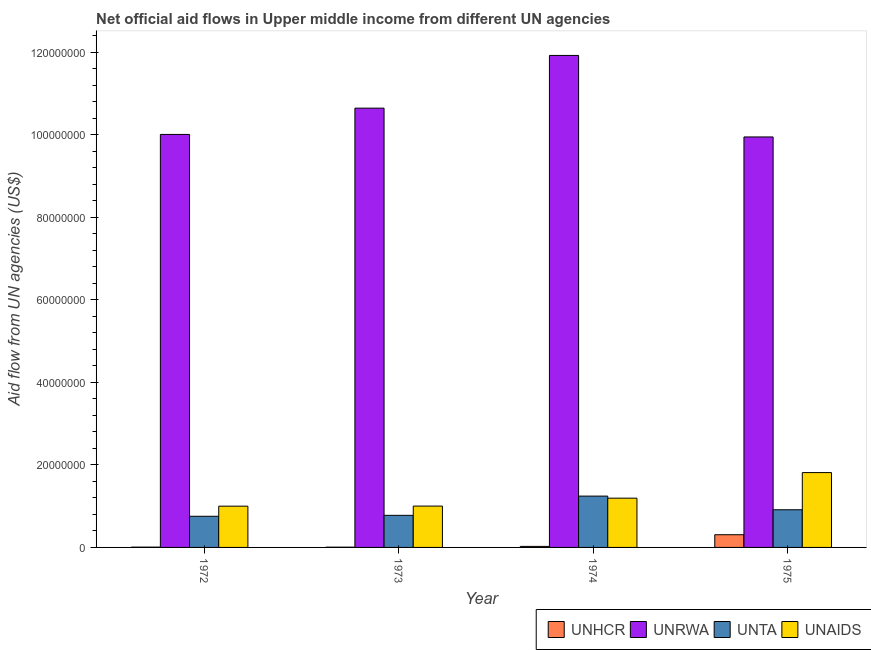How many groups of bars are there?
Offer a terse response. 4. Are the number of bars per tick equal to the number of legend labels?
Your answer should be very brief. Yes. How many bars are there on the 1st tick from the right?
Offer a terse response. 4. What is the label of the 4th group of bars from the left?
Provide a short and direct response. 1975. In how many cases, is the number of bars for a given year not equal to the number of legend labels?
Offer a terse response. 0. What is the amount of aid given by unta in 1974?
Provide a short and direct response. 1.24e+07. Across all years, what is the maximum amount of aid given by unaids?
Provide a short and direct response. 1.81e+07. Across all years, what is the minimum amount of aid given by unrwa?
Make the answer very short. 9.95e+07. In which year was the amount of aid given by unrwa maximum?
Make the answer very short. 1974. What is the total amount of aid given by unrwa in the graph?
Make the answer very short. 4.25e+08. What is the difference between the amount of aid given by unta in 1973 and that in 1974?
Give a very brief answer. -4.66e+06. What is the difference between the amount of aid given by unta in 1974 and the amount of aid given by unhcr in 1973?
Keep it short and to the point. 4.66e+06. What is the average amount of aid given by unaids per year?
Ensure brevity in your answer.  1.25e+07. In how many years, is the amount of aid given by unaids greater than 36000000 US$?
Offer a very short reply. 0. What is the ratio of the amount of aid given by unrwa in 1973 to that in 1974?
Your answer should be very brief. 0.89. What is the difference between the highest and the second highest amount of aid given by unaids?
Your answer should be compact. 6.20e+06. What is the difference between the highest and the lowest amount of aid given by unrwa?
Keep it short and to the point. 1.98e+07. Is the sum of the amount of aid given by unaids in 1972 and 1974 greater than the maximum amount of aid given by unrwa across all years?
Ensure brevity in your answer.  Yes. Is it the case that in every year, the sum of the amount of aid given by unta and amount of aid given by unaids is greater than the sum of amount of aid given by unhcr and amount of aid given by unrwa?
Your response must be concise. No. What does the 3rd bar from the left in 1975 represents?
Provide a short and direct response. UNTA. What does the 3rd bar from the right in 1972 represents?
Keep it short and to the point. UNRWA. How many bars are there?
Provide a succinct answer. 16. Are all the bars in the graph horizontal?
Your response must be concise. No. Does the graph contain any zero values?
Offer a terse response. No. Where does the legend appear in the graph?
Offer a very short reply. Bottom right. How are the legend labels stacked?
Keep it short and to the point. Horizontal. What is the title of the graph?
Provide a short and direct response. Net official aid flows in Upper middle income from different UN agencies. Does "Services" appear as one of the legend labels in the graph?
Make the answer very short. No. What is the label or title of the X-axis?
Your response must be concise. Year. What is the label or title of the Y-axis?
Your answer should be very brief. Aid flow from UN agencies (US$). What is the Aid flow from UN agencies (US$) of UNHCR in 1972?
Give a very brief answer. 7.00e+04. What is the Aid flow from UN agencies (US$) of UNRWA in 1972?
Ensure brevity in your answer.  1.00e+08. What is the Aid flow from UN agencies (US$) of UNTA in 1972?
Make the answer very short. 7.55e+06. What is the Aid flow from UN agencies (US$) in UNAIDS in 1972?
Your answer should be very brief. 1.00e+07. What is the Aid flow from UN agencies (US$) in UNHCR in 1973?
Give a very brief answer. 6.00e+04. What is the Aid flow from UN agencies (US$) of UNRWA in 1973?
Make the answer very short. 1.06e+08. What is the Aid flow from UN agencies (US$) in UNTA in 1973?
Offer a very short reply. 7.78e+06. What is the Aid flow from UN agencies (US$) in UNAIDS in 1973?
Provide a succinct answer. 1.00e+07. What is the Aid flow from UN agencies (US$) in UNHCR in 1974?
Offer a terse response. 2.50e+05. What is the Aid flow from UN agencies (US$) in UNRWA in 1974?
Your answer should be very brief. 1.19e+08. What is the Aid flow from UN agencies (US$) of UNTA in 1974?
Provide a short and direct response. 1.24e+07. What is the Aid flow from UN agencies (US$) of UNAIDS in 1974?
Your answer should be compact. 1.19e+07. What is the Aid flow from UN agencies (US$) in UNHCR in 1975?
Your response must be concise. 3.08e+06. What is the Aid flow from UN agencies (US$) in UNRWA in 1975?
Offer a very short reply. 9.95e+07. What is the Aid flow from UN agencies (US$) of UNTA in 1975?
Your answer should be compact. 9.13e+06. What is the Aid flow from UN agencies (US$) in UNAIDS in 1975?
Provide a succinct answer. 1.81e+07. Across all years, what is the maximum Aid flow from UN agencies (US$) of UNHCR?
Make the answer very short. 3.08e+06. Across all years, what is the maximum Aid flow from UN agencies (US$) in UNRWA?
Make the answer very short. 1.19e+08. Across all years, what is the maximum Aid flow from UN agencies (US$) in UNTA?
Your answer should be compact. 1.24e+07. Across all years, what is the maximum Aid flow from UN agencies (US$) in UNAIDS?
Your answer should be compact. 1.81e+07. Across all years, what is the minimum Aid flow from UN agencies (US$) of UNHCR?
Your answer should be very brief. 6.00e+04. Across all years, what is the minimum Aid flow from UN agencies (US$) in UNRWA?
Keep it short and to the point. 9.95e+07. Across all years, what is the minimum Aid flow from UN agencies (US$) in UNTA?
Your answer should be compact. 7.55e+06. Across all years, what is the minimum Aid flow from UN agencies (US$) in UNAIDS?
Offer a very short reply. 1.00e+07. What is the total Aid flow from UN agencies (US$) in UNHCR in the graph?
Make the answer very short. 3.46e+06. What is the total Aid flow from UN agencies (US$) in UNRWA in the graph?
Keep it short and to the point. 4.25e+08. What is the total Aid flow from UN agencies (US$) of UNTA in the graph?
Your answer should be compact. 3.69e+07. What is the total Aid flow from UN agencies (US$) of UNAIDS in the graph?
Offer a terse response. 5.01e+07. What is the difference between the Aid flow from UN agencies (US$) in UNRWA in 1972 and that in 1973?
Offer a terse response. -6.37e+06. What is the difference between the Aid flow from UN agencies (US$) in UNTA in 1972 and that in 1973?
Ensure brevity in your answer.  -2.30e+05. What is the difference between the Aid flow from UN agencies (US$) in UNHCR in 1972 and that in 1974?
Keep it short and to the point. -1.80e+05. What is the difference between the Aid flow from UN agencies (US$) in UNRWA in 1972 and that in 1974?
Ensure brevity in your answer.  -1.92e+07. What is the difference between the Aid flow from UN agencies (US$) of UNTA in 1972 and that in 1974?
Your answer should be very brief. -4.89e+06. What is the difference between the Aid flow from UN agencies (US$) in UNAIDS in 1972 and that in 1974?
Offer a very short reply. -1.94e+06. What is the difference between the Aid flow from UN agencies (US$) in UNHCR in 1972 and that in 1975?
Offer a very short reply. -3.01e+06. What is the difference between the Aid flow from UN agencies (US$) of UNRWA in 1972 and that in 1975?
Give a very brief answer. 6.10e+05. What is the difference between the Aid flow from UN agencies (US$) of UNTA in 1972 and that in 1975?
Your answer should be very brief. -1.58e+06. What is the difference between the Aid flow from UN agencies (US$) of UNAIDS in 1972 and that in 1975?
Offer a very short reply. -8.14e+06. What is the difference between the Aid flow from UN agencies (US$) in UNRWA in 1973 and that in 1974?
Your answer should be very brief. -1.28e+07. What is the difference between the Aid flow from UN agencies (US$) of UNTA in 1973 and that in 1974?
Your answer should be very brief. -4.66e+06. What is the difference between the Aid flow from UN agencies (US$) in UNAIDS in 1973 and that in 1974?
Give a very brief answer. -1.92e+06. What is the difference between the Aid flow from UN agencies (US$) in UNHCR in 1973 and that in 1975?
Your response must be concise. -3.02e+06. What is the difference between the Aid flow from UN agencies (US$) in UNRWA in 1973 and that in 1975?
Offer a very short reply. 6.98e+06. What is the difference between the Aid flow from UN agencies (US$) of UNTA in 1973 and that in 1975?
Ensure brevity in your answer.  -1.35e+06. What is the difference between the Aid flow from UN agencies (US$) in UNAIDS in 1973 and that in 1975?
Offer a terse response. -8.12e+06. What is the difference between the Aid flow from UN agencies (US$) of UNHCR in 1974 and that in 1975?
Your response must be concise. -2.83e+06. What is the difference between the Aid flow from UN agencies (US$) of UNRWA in 1974 and that in 1975?
Give a very brief answer. 1.98e+07. What is the difference between the Aid flow from UN agencies (US$) in UNTA in 1974 and that in 1975?
Your response must be concise. 3.31e+06. What is the difference between the Aid flow from UN agencies (US$) of UNAIDS in 1974 and that in 1975?
Provide a succinct answer. -6.20e+06. What is the difference between the Aid flow from UN agencies (US$) in UNHCR in 1972 and the Aid flow from UN agencies (US$) in UNRWA in 1973?
Your answer should be very brief. -1.06e+08. What is the difference between the Aid flow from UN agencies (US$) in UNHCR in 1972 and the Aid flow from UN agencies (US$) in UNTA in 1973?
Ensure brevity in your answer.  -7.71e+06. What is the difference between the Aid flow from UN agencies (US$) in UNHCR in 1972 and the Aid flow from UN agencies (US$) in UNAIDS in 1973?
Your answer should be compact. -9.95e+06. What is the difference between the Aid flow from UN agencies (US$) in UNRWA in 1972 and the Aid flow from UN agencies (US$) in UNTA in 1973?
Your answer should be compact. 9.23e+07. What is the difference between the Aid flow from UN agencies (US$) in UNRWA in 1972 and the Aid flow from UN agencies (US$) in UNAIDS in 1973?
Provide a succinct answer. 9.01e+07. What is the difference between the Aid flow from UN agencies (US$) of UNTA in 1972 and the Aid flow from UN agencies (US$) of UNAIDS in 1973?
Your answer should be compact. -2.47e+06. What is the difference between the Aid flow from UN agencies (US$) in UNHCR in 1972 and the Aid flow from UN agencies (US$) in UNRWA in 1974?
Provide a succinct answer. -1.19e+08. What is the difference between the Aid flow from UN agencies (US$) of UNHCR in 1972 and the Aid flow from UN agencies (US$) of UNTA in 1974?
Provide a succinct answer. -1.24e+07. What is the difference between the Aid flow from UN agencies (US$) of UNHCR in 1972 and the Aid flow from UN agencies (US$) of UNAIDS in 1974?
Make the answer very short. -1.19e+07. What is the difference between the Aid flow from UN agencies (US$) of UNRWA in 1972 and the Aid flow from UN agencies (US$) of UNTA in 1974?
Provide a succinct answer. 8.77e+07. What is the difference between the Aid flow from UN agencies (US$) of UNRWA in 1972 and the Aid flow from UN agencies (US$) of UNAIDS in 1974?
Provide a short and direct response. 8.82e+07. What is the difference between the Aid flow from UN agencies (US$) of UNTA in 1972 and the Aid flow from UN agencies (US$) of UNAIDS in 1974?
Your response must be concise. -4.39e+06. What is the difference between the Aid flow from UN agencies (US$) in UNHCR in 1972 and the Aid flow from UN agencies (US$) in UNRWA in 1975?
Offer a very short reply. -9.94e+07. What is the difference between the Aid flow from UN agencies (US$) in UNHCR in 1972 and the Aid flow from UN agencies (US$) in UNTA in 1975?
Your response must be concise. -9.06e+06. What is the difference between the Aid flow from UN agencies (US$) in UNHCR in 1972 and the Aid flow from UN agencies (US$) in UNAIDS in 1975?
Offer a very short reply. -1.81e+07. What is the difference between the Aid flow from UN agencies (US$) in UNRWA in 1972 and the Aid flow from UN agencies (US$) in UNTA in 1975?
Give a very brief answer. 9.10e+07. What is the difference between the Aid flow from UN agencies (US$) of UNRWA in 1972 and the Aid flow from UN agencies (US$) of UNAIDS in 1975?
Provide a succinct answer. 8.20e+07. What is the difference between the Aid flow from UN agencies (US$) of UNTA in 1972 and the Aid flow from UN agencies (US$) of UNAIDS in 1975?
Make the answer very short. -1.06e+07. What is the difference between the Aid flow from UN agencies (US$) in UNHCR in 1973 and the Aid flow from UN agencies (US$) in UNRWA in 1974?
Your response must be concise. -1.19e+08. What is the difference between the Aid flow from UN agencies (US$) in UNHCR in 1973 and the Aid flow from UN agencies (US$) in UNTA in 1974?
Provide a succinct answer. -1.24e+07. What is the difference between the Aid flow from UN agencies (US$) in UNHCR in 1973 and the Aid flow from UN agencies (US$) in UNAIDS in 1974?
Keep it short and to the point. -1.19e+07. What is the difference between the Aid flow from UN agencies (US$) in UNRWA in 1973 and the Aid flow from UN agencies (US$) in UNTA in 1974?
Your answer should be compact. 9.40e+07. What is the difference between the Aid flow from UN agencies (US$) in UNRWA in 1973 and the Aid flow from UN agencies (US$) in UNAIDS in 1974?
Provide a succinct answer. 9.45e+07. What is the difference between the Aid flow from UN agencies (US$) in UNTA in 1973 and the Aid flow from UN agencies (US$) in UNAIDS in 1974?
Your answer should be very brief. -4.16e+06. What is the difference between the Aid flow from UN agencies (US$) in UNHCR in 1973 and the Aid flow from UN agencies (US$) in UNRWA in 1975?
Offer a terse response. -9.94e+07. What is the difference between the Aid flow from UN agencies (US$) of UNHCR in 1973 and the Aid flow from UN agencies (US$) of UNTA in 1975?
Offer a terse response. -9.07e+06. What is the difference between the Aid flow from UN agencies (US$) in UNHCR in 1973 and the Aid flow from UN agencies (US$) in UNAIDS in 1975?
Give a very brief answer. -1.81e+07. What is the difference between the Aid flow from UN agencies (US$) in UNRWA in 1973 and the Aid flow from UN agencies (US$) in UNTA in 1975?
Ensure brevity in your answer.  9.74e+07. What is the difference between the Aid flow from UN agencies (US$) in UNRWA in 1973 and the Aid flow from UN agencies (US$) in UNAIDS in 1975?
Provide a succinct answer. 8.83e+07. What is the difference between the Aid flow from UN agencies (US$) in UNTA in 1973 and the Aid flow from UN agencies (US$) in UNAIDS in 1975?
Offer a terse response. -1.04e+07. What is the difference between the Aid flow from UN agencies (US$) in UNHCR in 1974 and the Aid flow from UN agencies (US$) in UNRWA in 1975?
Provide a succinct answer. -9.92e+07. What is the difference between the Aid flow from UN agencies (US$) of UNHCR in 1974 and the Aid flow from UN agencies (US$) of UNTA in 1975?
Make the answer very short. -8.88e+06. What is the difference between the Aid flow from UN agencies (US$) in UNHCR in 1974 and the Aid flow from UN agencies (US$) in UNAIDS in 1975?
Give a very brief answer. -1.79e+07. What is the difference between the Aid flow from UN agencies (US$) of UNRWA in 1974 and the Aid flow from UN agencies (US$) of UNTA in 1975?
Give a very brief answer. 1.10e+08. What is the difference between the Aid flow from UN agencies (US$) of UNRWA in 1974 and the Aid flow from UN agencies (US$) of UNAIDS in 1975?
Give a very brief answer. 1.01e+08. What is the difference between the Aid flow from UN agencies (US$) of UNTA in 1974 and the Aid flow from UN agencies (US$) of UNAIDS in 1975?
Ensure brevity in your answer.  -5.70e+06. What is the average Aid flow from UN agencies (US$) of UNHCR per year?
Provide a short and direct response. 8.65e+05. What is the average Aid flow from UN agencies (US$) in UNRWA per year?
Offer a very short reply. 1.06e+08. What is the average Aid flow from UN agencies (US$) of UNTA per year?
Make the answer very short. 9.22e+06. What is the average Aid flow from UN agencies (US$) of UNAIDS per year?
Your answer should be very brief. 1.25e+07. In the year 1972, what is the difference between the Aid flow from UN agencies (US$) of UNHCR and Aid flow from UN agencies (US$) of UNRWA?
Your response must be concise. -1.00e+08. In the year 1972, what is the difference between the Aid flow from UN agencies (US$) of UNHCR and Aid flow from UN agencies (US$) of UNTA?
Provide a short and direct response. -7.48e+06. In the year 1972, what is the difference between the Aid flow from UN agencies (US$) in UNHCR and Aid flow from UN agencies (US$) in UNAIDS?
Offer a very short reply. -9.93e+06. In the year 1972, what is the difference between the Aid flow from UN agencies (US$) in UNRWA and Aid flow from UN agencies (US$) in UNTA?
Offer a very short reply. 9.26e+07. In the year 1972, what is the difference between the Aid flow from UN agencies (US$) of UNRWA and Aid flow from UN agencies (US$) of UNAIDS?
Keep it short and to the point. 9.01e+07. In the year 1972, what is the difference between the Aid flow from UN agencies (US$) in UNTA and Aid flow from UN agencies (US$) in UNAIDS?
Offer a very short reply. -2.45e+06. In the year 1973, what is the difference between the Aid flow from UN agencies (US$) in UNHCR and Aid flow from UN agencies (US$) in UNRWA?
Give a very brief answer. -1.06e+08. In the year 1973, what is the difference between the Aid flow from UN agencies (US$) in UNHCR and Aid flow from UN agencies (US$) in UNTA?
Your answer should be very brief. -7.72e+06. In the year 1973, what is the difference between the Aid flow from UN agencies (US$) of UNHCR and Aid flow from UN agencies (US$) of UNAIDS?
Your response must be concise. -9.96e+06. In the year 1973, what is the difference between the Aid flow from UN agencies (US$) of UNRWA and Aid flow from UN agencies (US$) of UNTA?
Offer a terse response. 9.87e+07. In the year 1973, what is the difference between the Aid flow from UN agencies (US$) of UNRWA and Aid flow from UN agencies (US$) of UNAIDS?
Keep it short and to the point. 9.65e+07. In the year 1973, what is the difference between the Aid flow from UN agencies (US$) of UNTA and Aid flow from UN agencies (US$) of UNAIDS?
Your answer should be compact. -2.24e+06. In the year 1974, what is the difference between the Aid flow from UN agencies (US$) in UNHCR and Aid flow from UN agencies (US$) in UNRWA?
Provide a short and direct response. -1.19e+08. In the year 1974, what is the difference between the Aid flow from UN agencies (US$) in UNHCR and Aid flow from UN agencies (US$) in UNTA?
Keep it short and to the point. -1.22e+07. In the year 1974, what is the difference between the Aid flow from UN agencies (US$) of UNHCR and Aid flow from UN agencies (US$) of UNAIDS?
Give a very brief answer. -1.17e+07. In the year 1974, what is the difference between the Aid flow from UN agencies (US$) in UNRWA and Aid flow from UN agencies (US$) in UNTA?
Make the answer very short. 1.07e+08. In the year 1974, what is the difference between the Aid flow from UN agencies (US$) of UNRWA and Aid flow from UN agencies (US$) of UNAIDS?
Ensure brevity in your answer.  1.07e+08. In the year 1974, what is the difference between the Aid flow from UN agencies (US$) of UNTA and Aid flow from UN agencies (US$) of UNAIDS?
Your response must be concise. 5.00e+05. In the year 1975, what is the difference between the Aid flow from UN agencies (US$) in UNHCR and Aid flow from UN agencies (US$) in UNRWA?
Ensure brevity in your answer.  -9.64e+07. In the year 1975, what is the difference between the Aid flow from UN agencies (US$) of UNHCR and Aid flow from UN agencies (US$) of UNTA?
Offer a terse response. -6.05e+06. In the year 1975, what is the difference between the Aid flow from UN agencies (US$) of UNHCR and Aid flow from UN agencies (US$) of UNAIDS?
Provide a succinct answer. -1.51e+07. In the year 1975, what is the difference between the Aid flow from UN agencies (US$) of UNRWA and Aid flow from UN agencies (US$) of UNTA?
Ensure brevity in your answer.  9.04e+07. In the year 1975, what is the difference between the Aid flow from UN agencies (US$) in UNRWA and Aid flow from UN agencies (US$) in UNAIDS?
Offer a very short reply. 8.14e+07. In the year 1975, what is the difference between the Aid flow from UN agencies (US$) in UNTA and Aid flow from UN agencies (US$) in UNAIDS?
Offer a very short reply. -9.01e+06. What is the ratio of the Aid flow from UN agencies (US$) of UNHCR in 1972 to that in 1973?
Offer a terse response. 1.17. What is the ratio of the Aid flow from UN agencies (US$) in UNRWA in 1972 to that in 1973?
Offer a terse response. 0.94. What is the ratio of the Aid flow from UN agencies (US$) in UNTA in 1972 to that in 1973?
Offer a terse response. 0.97. What is the ratio of the Aid flow from UN agencies (US$) of UNAIDS in 1972 to that in 1973?
Provide a short and direct response. 1. What is the ratio of the Aid flow from UN agencies (US$) in UNHCR in 1972 to that in 1974?
Provide a succinct answer. 0.28. What is the ratio of the Aid flow from UN agencies (US$) of UNRWA in 1972 to that in 1974?
Your answer should be very brief. 0.84. What is the ratio of the Aid flow from UN agencies (US$) of UNTA in 1972 to that in 1974?
Your answer should be compact. 0.61. What is the ratio of the Aid flow from UN agencies (US$) of UNAIDS in 1972 to that in 1974?
Offer a terse response. 0.84. What is the ratio of the Aid flow from UN agencies (US$) of UNHCR in 1972 to that in 1975?
Provide a succinct answer. 0.02. What is the ratio of the Aid flow from UN agencies (US$) of UNRWA in 1972 to that in 1975?
Provide a short and direct response. 1.01. What is the ratio of the Aid flow from UN agencies (US$) in UNTA in 1972 to that in 1975?
Your response must be concise. 0.83. What is the ratio of the Aid flow from UN agencies (US$) in UNAIDS in 1972 to that in 1975?
Provide a short and direct response. 0.55. What is the ratio of the Aid flow from UN agencies (US$) in UNHCR in 1973 to that in 1974?
Make the answer very short. 0.24. What is the ratio of the Aid flow from UN agencies (US$) in UNRWA in 1973 to that in 1974?
Keep it short and to the point. 0.89. What is the ratio of the Aid flow from UN agencies (US$) in UNTA in 1973 to that in 1974?
Your answer should be compact. 0.63. What is the ratio of the Aid flow from UN agencies (US$) of UNAIDS in 1973 to that in 1974?
Offer a terse response. 0.84. What is the ratio of the Aid flow from UN agencies (US$) in UNHCR in 1973 to that in 1975?
Make the answer very short. 0.02. What is the ratio of the Aid flow from UN agencies (US$) of UNRWA in 1973 to that in 1975?
Your response must be concise. 1.07. What is the ratio of the Aid flow from UN agencies (US$) of UNTA in 1973 to that in 1975?
Your response must be concise. 0.85. What is the ratio of the Aid flow from UN agencies (US$) in UNAIDS in 1973 to that in 1975?
Offer a very short reply. 0.55. What is the ratio of the Aid flow from UN agencies (US$) in UNHCR in 1974 to that in 1975?
Ensure brevity in your answer.  0.08. What is the ratio of the Aid flow from UN agencies (US$) of UNRWA in 1974 to that in 1975?
Make the answer very short. 1.2. What is the ratio of the Aid flow from UN agencies (US$) of UNTA in 1974 to that in 1975?
Your answer should be compact. 1.36. What is the ratio of the Aid flow from UN agencies (US$) of UNAIDS in 1974 to that in 1975?
Make the answer very short. 0.66. What is the difference between the highest and the second highest Aid flow from UN agencies (US$) of UNHCR?
Keep it short and to the point. 2.83e+06. What is the difference between the highest and the second highest Aid flow from UN agencies (US$) of UNRWA?
Make the answer very short. 1.28e+07. What is the difference between the highest and the second highest Aid flow from UN agencies (US$) of UNTA?
Offer a very short reply. 3.31e+06. What is the difference between the highest and the second highest Aid flow from UN agencies (US$) in UNAIDS?
Give a very brief answer. 6.20e+06. What is the difference between the highest and the lowest Aid flow from UN agencies (US$) in UNHCR?
Your answer should be compact. 3.02e+06. What is the difference between the highest and the lowest Aid flow from UN agencies (US$) in UNRWA?
Give a very brief answer. 1.98e+07. What is the difference between the highest and the lowest Aid flow from UN agencies (US$) in UNTA?
Ensure brevity in your answer.  4.89e+06. What is the difference between the highest and the lowest Aid flow from UN agencies (US$) in UNAIDS?
Your answer should be very brief. 8.14e+06. 